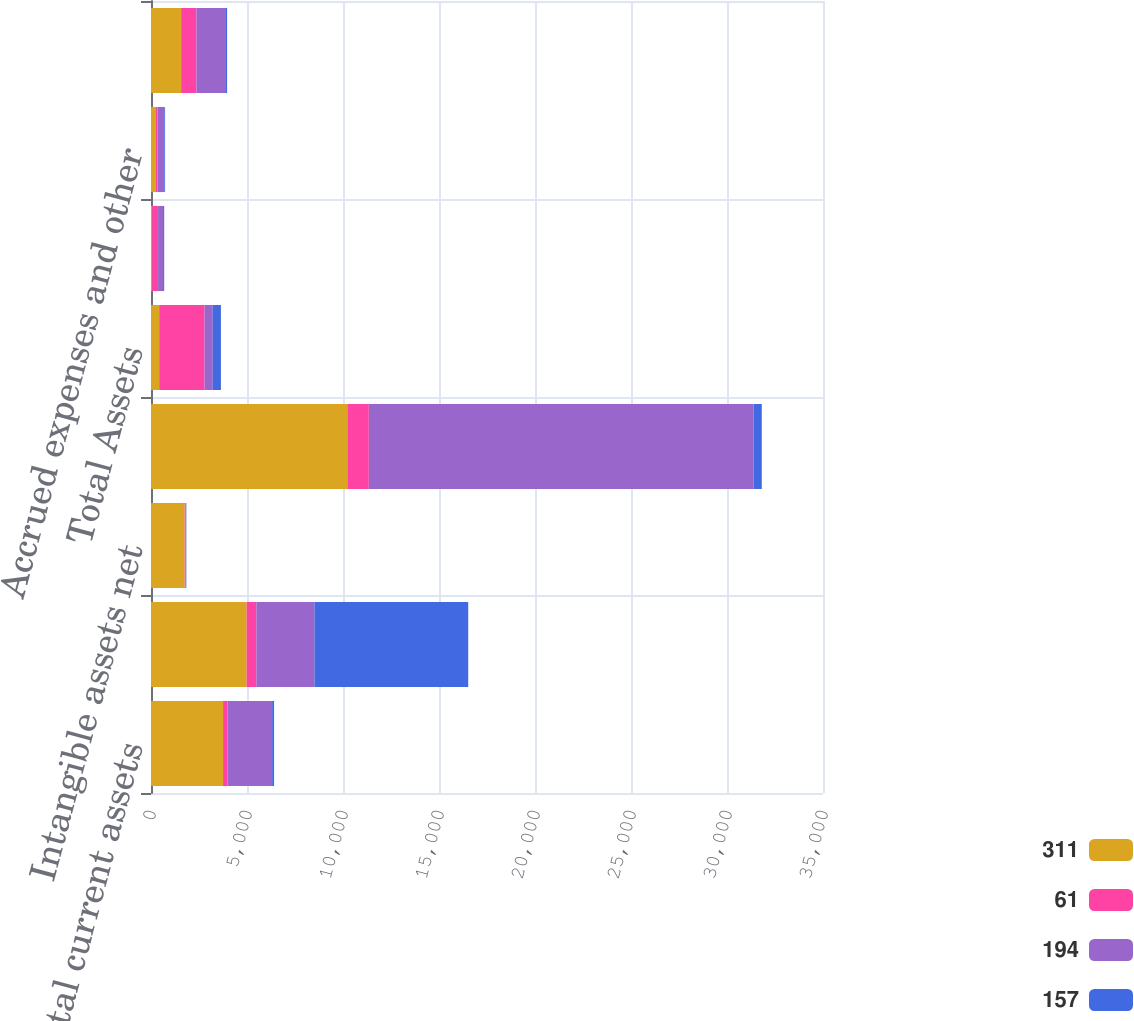Convert chart. <chart><loc_0><loc_0><loc_500><loc_500><stacked_bar_chart><ecel><fcel>Total current assets<fcel>Capital leases and note<fcel>Intangible assets net<fcel>Total other assets<fcel>Total Assets<fcel>Current portion of long-term<fcel>Accrued expenses and other<fcel>Total current liabilities<nl><fcel>311<fcel>3753<fcel>4982<fcel>1755<fcel>10224<fcel>425.5<fcel>58<fcel>261<fcel>1569<nl><fcel>61<fcel>235<fcel>504<fcel>20<fcel>1121<fcel>2365<fcel>310<fcel>82<fcel>798<nl><fcel>194<fcel>2321<fcel>3027<fcel>33<fcel>20041<fcel>425.5<fcel>261<fcel>347<fcel>1496<nl><fcel>157<fcel>101<fcel>8009<fcel>31<fcel>425.5<fcel>425.5<fcel>58<fcel>43<fcel>101<nl></chart> 